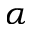Convert formula to latex. <formula><loc_0><loc_0><loc_500><loc_500>\alpha</formula> 